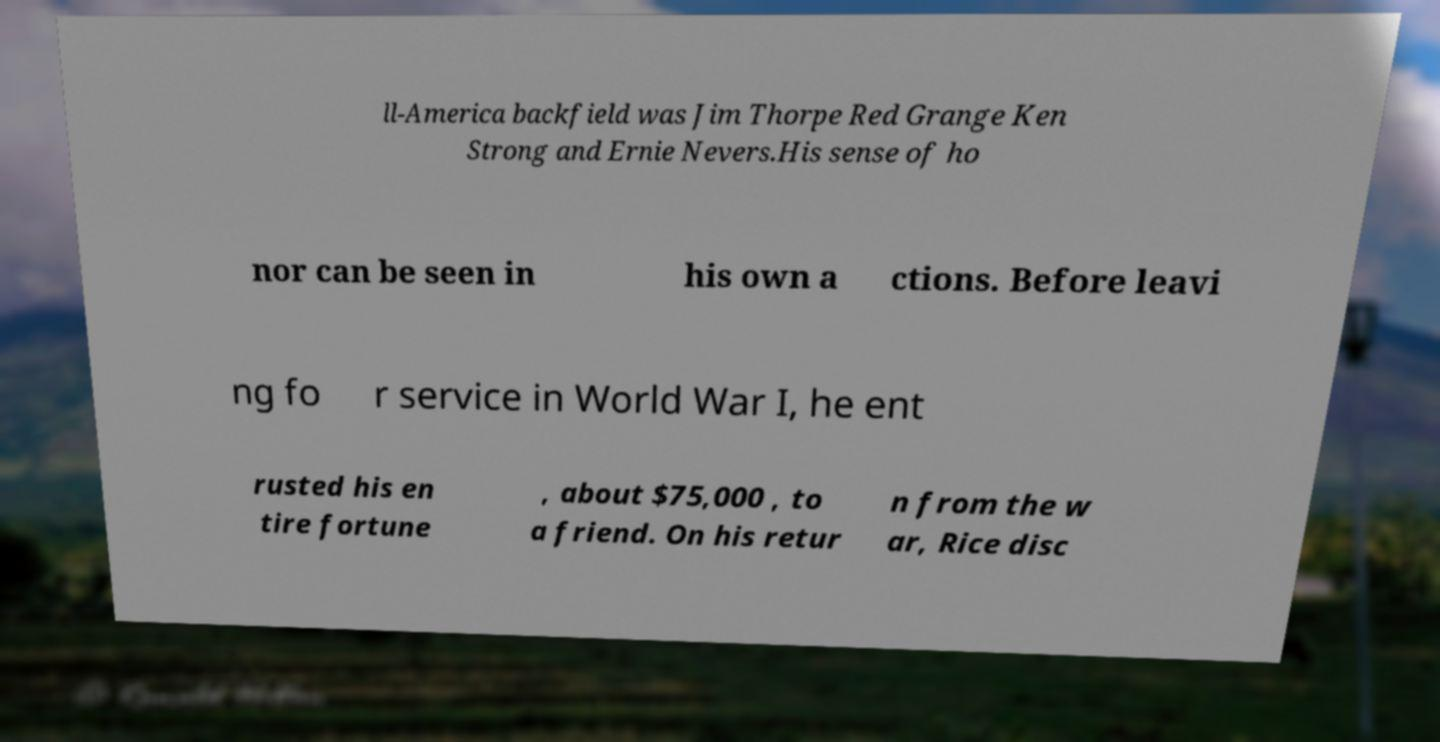I need the written content from this picture converted into text. Can you do that? ll-America backfield was Jim Thorpe Red Grange Ken Strong and Ernie Nevers.His sense of ho nor can be seen in his own a ctions. Before leavi ng fo r service in World War I, he ent rusted his en tire fortune , about $75,000 , to a friend. On his retur n from the w ar, Rice disc 